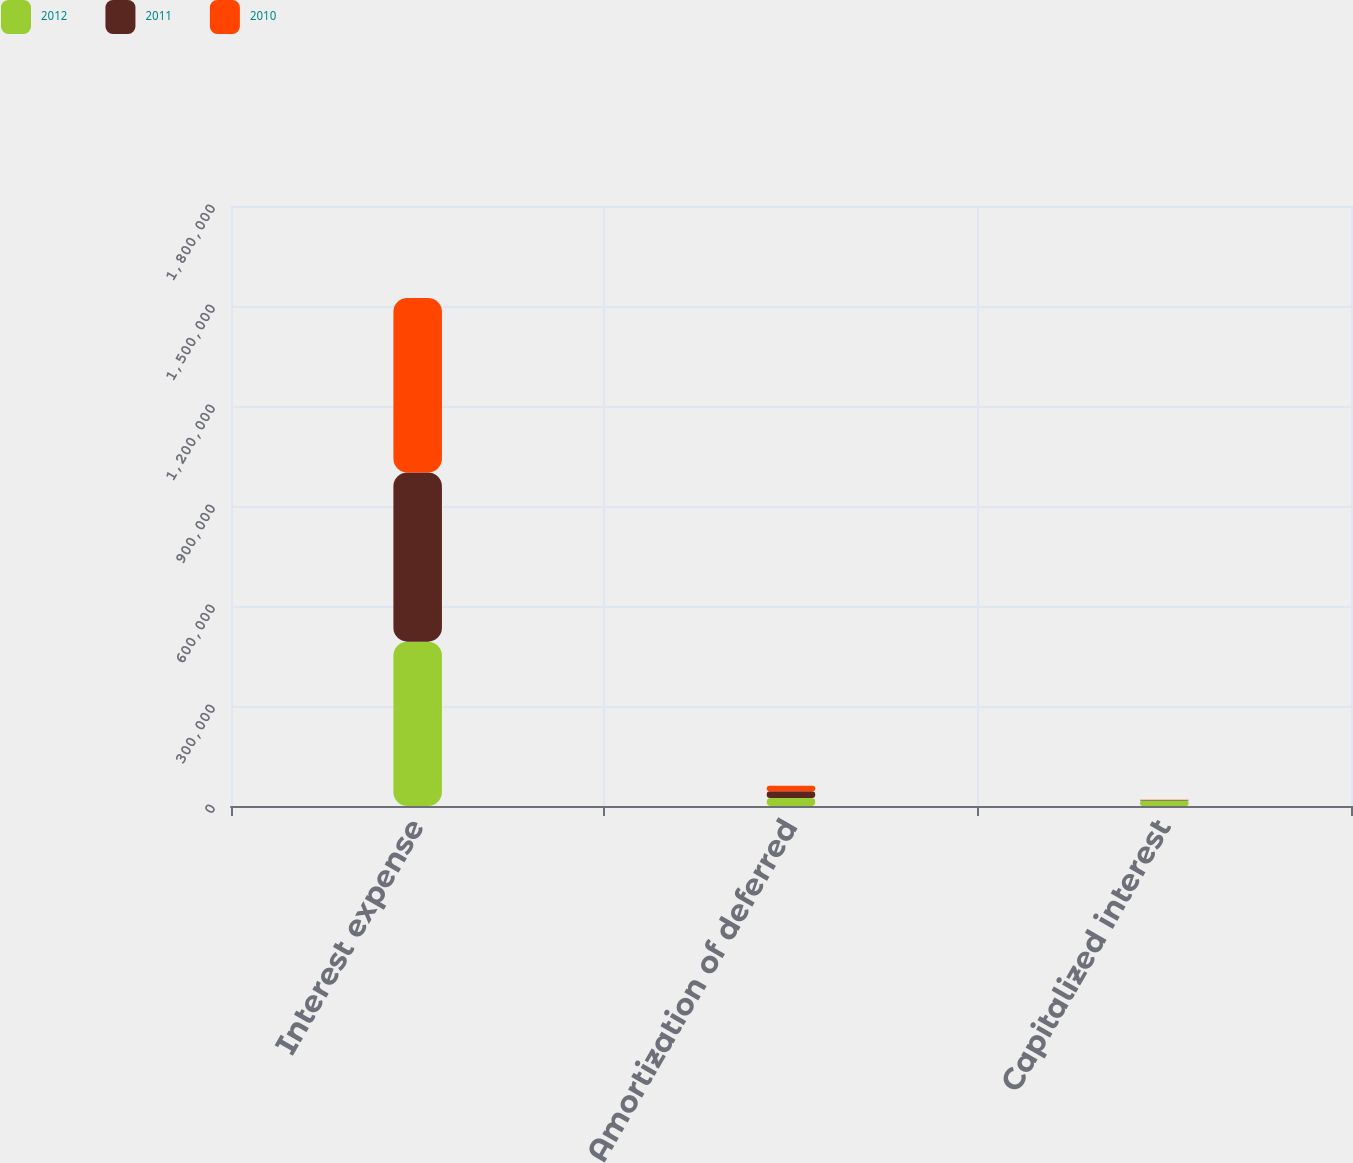<chart> <loc_0><loc_0><loc_500><loc_500><stacked_bar_chart><ecel><fcel>Interest expense<fcel>Amortization of deferred<fcel>Capitalized interest<nl><fcel>2012<fcel>493067<fcel>24095<fcel>16801<nl><fcel>2011<fcel>507387<fcel>19985<fcel>1197<nl><fcel>2010<fcel>523905<fcel>16329<fcel>864<nl></chart> 